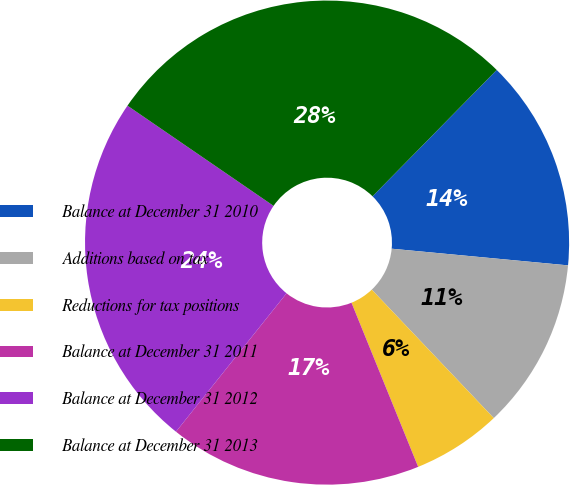Convert chart to OTSL. <chart><loc_0><loc_0><loc_500><loc_500><pie_chart><fcel>Balance at December 31 2010<fcel>Additions based on tax<fcel>Reductions for tax positions<fcel>Balance at December 31 2011<fcel>Balance at December 31 2012<fcel>Balance at December 31 2013<nl><fcel>14.14%<fcel>11.41%<fcel>5.95%<fcel>16.87%<fcel>23.84%<fcel>27.79%<nl></chart> 